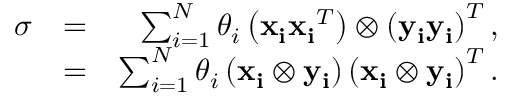Convert formula to latex. <formula><loc_0><loc_0><loc_500><loc_500>\begin{array} { r l r } { \sigma } & { = } & { \sum _ { i = 1 } ^ { N } \theta _ { i } \left ( x _ { i } x _ { i } ^ { T } \right ) \otimes \left ( \mathbf { y _ { i } } \mathbf { y _ { i } } \right ) ^ { T } , } \\ & { = } & { \sum _ { i = 1 } ^ { N } \theta _ { i } \left ( \mathbf { x _ { i } } \otimes \mathbf { y _ { i } } \right ) \left ( x _ { i } \otimes \mathbf { y _ { i } } \right ) ^ { T } . } \end{array}</formula> 